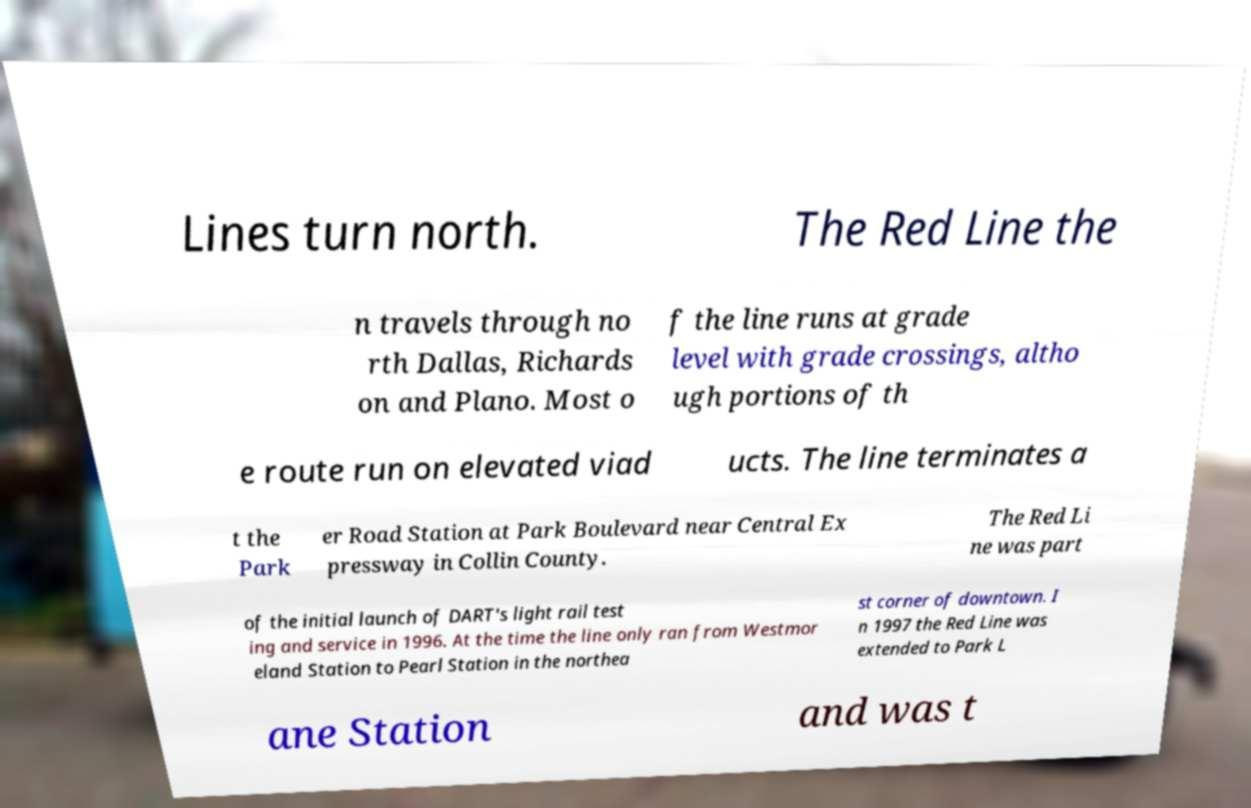I need the written content from this picture converted into text. Can you do that? Lines turn north. The Red Line the n travels through no rth Dallas, Richards on and Plano. Most o f the line runs at grade level with grade crossings, altho ugh portions of th e route run on elevated viad ucts. The line terminates a t the Park er Road Station at Park Boulevard near Central Ex pressway in Collin County. The Red Li ne was part of the initial launch of DART's light rail test ing and service in 1996. At the time the line only ran from Westmor eland Station to Pearl Station in the northea st corner of downtown. I n 1997 the Red Line was extended to Park L ane Station and was t 